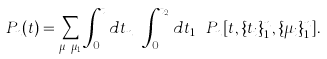Convert formula to latex. <formula><loc_0><loc_0><loc_500><loc_500>P _ { n } ( t ) = \sum _ { \mu _ { n } \cdots \mu _ { 1 } } \int _ { 0 } ^ { t } d t _ { n } \cdots \int _ { 0 } ^ { t _ { 2 } } d t _ { 1 } \ P _ { n } [ t , \{ t _ { i } \} _ { 1 } ^ { n } , \{ \mu _ { i } \} _ { 1 } ^ { n } ] .</formula> 